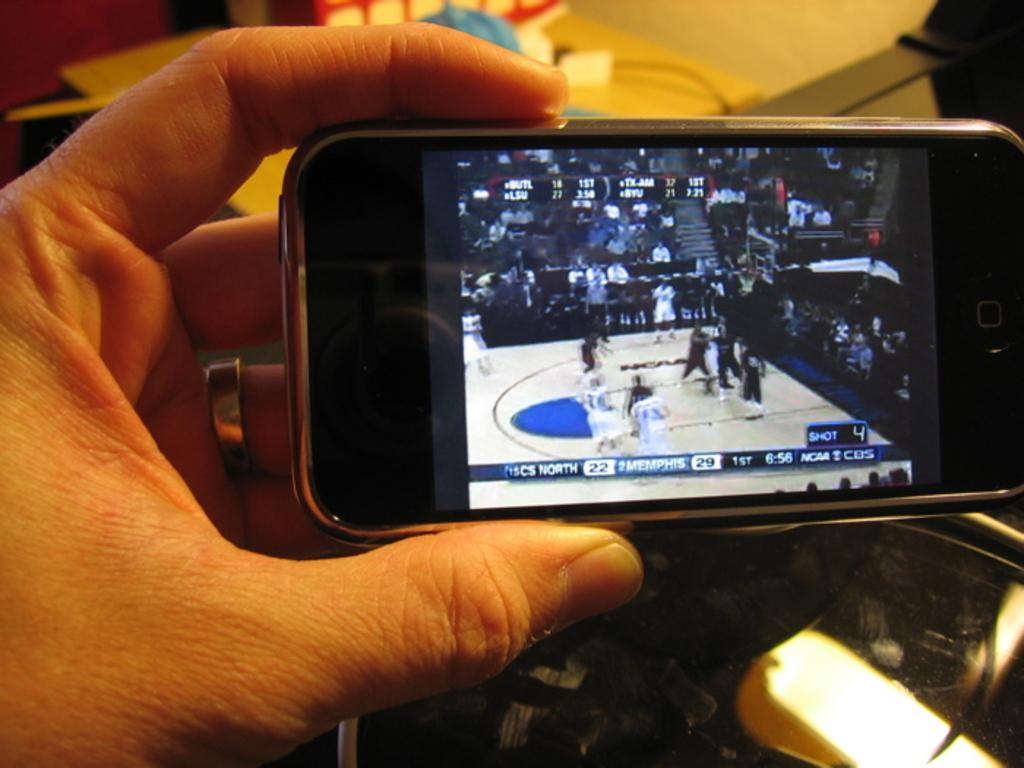<image>
Offer a succinct explanation of the picture presented. A person is holding a phone that is showing a basketball game and a score of 22 for CS NORTH and 29 for MEMPHIS. 